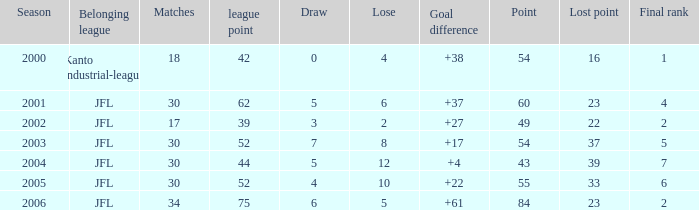Tell me the average final rank for loe more than 10 and point less than 43 None. 